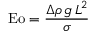Convert formula to latex. <formula><loc_0><loc_0><loc_500><loc_500>E o = { \frac { \Delta \rho \, g \, L ^ { 2 } } { \sigma } }</formula> 